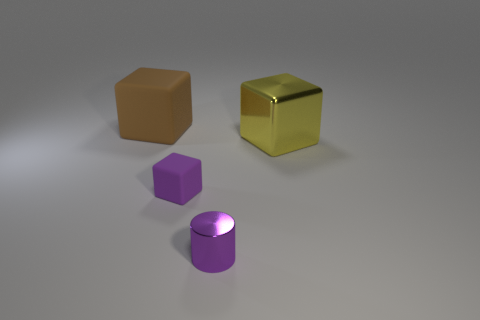Subtract 1 blocks. How many blocks are left? 2 Subtract all big cubes. How many cubes are left? 1 Add 2 yellow cubes. How many objects exist? 6 Subtract all cylinders. How many objects are left? 3 Add 3 rubber blocks. How many rubber blocks are left? 5 Add 3 small purple metallic cylinders. How many small purple metallic cylinders exist? 4 Subtract 0 blue cylinders. How many objects are left? 4 Subtract all small blue matte objects. Subtract all small shiny cylinders. How many objects are left? 3 